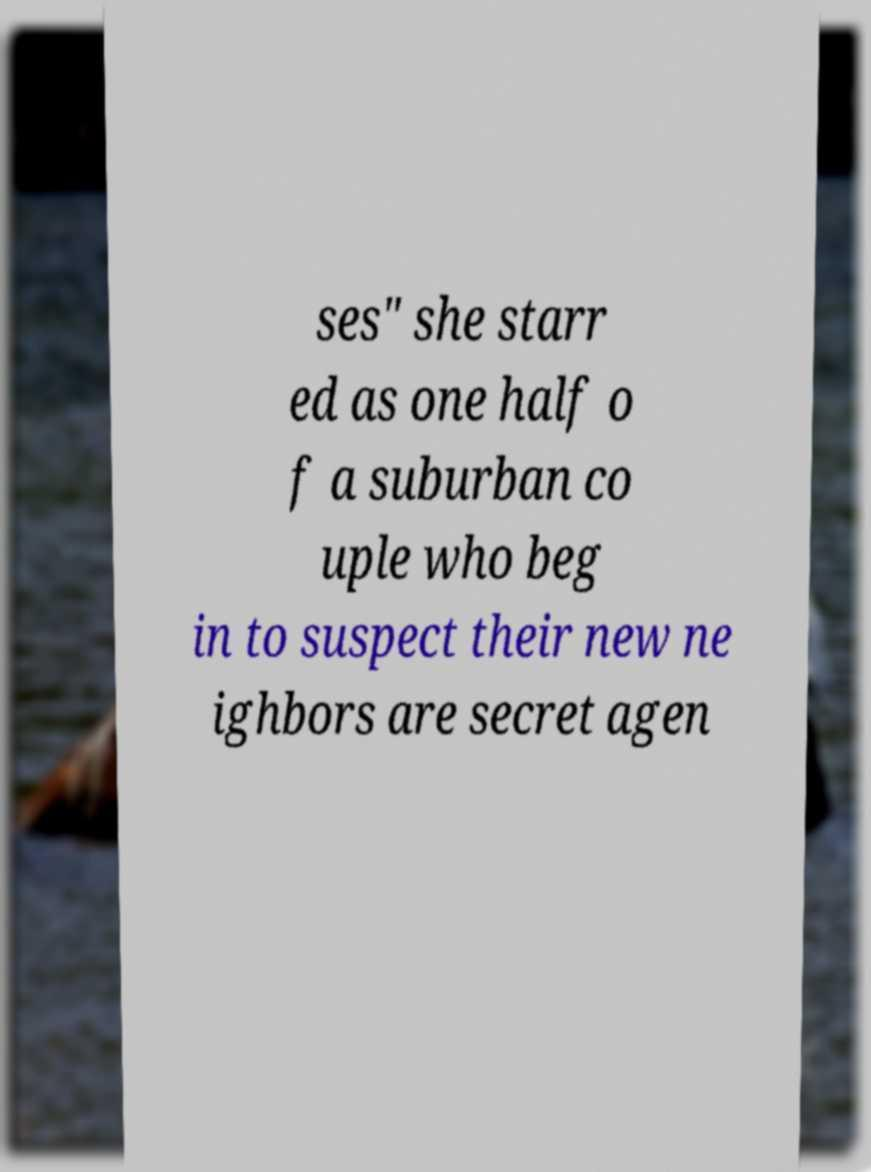Could you extract and type out the text from this image? ses" she starr ed as one half o f a suburban co uple who beg in to suspect their new ne ighbors are secret agen 